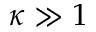Convert formula to latex. <formula><loc_0><loc_0><loc_500><loc_500>\kappa \gg 1</formula> 